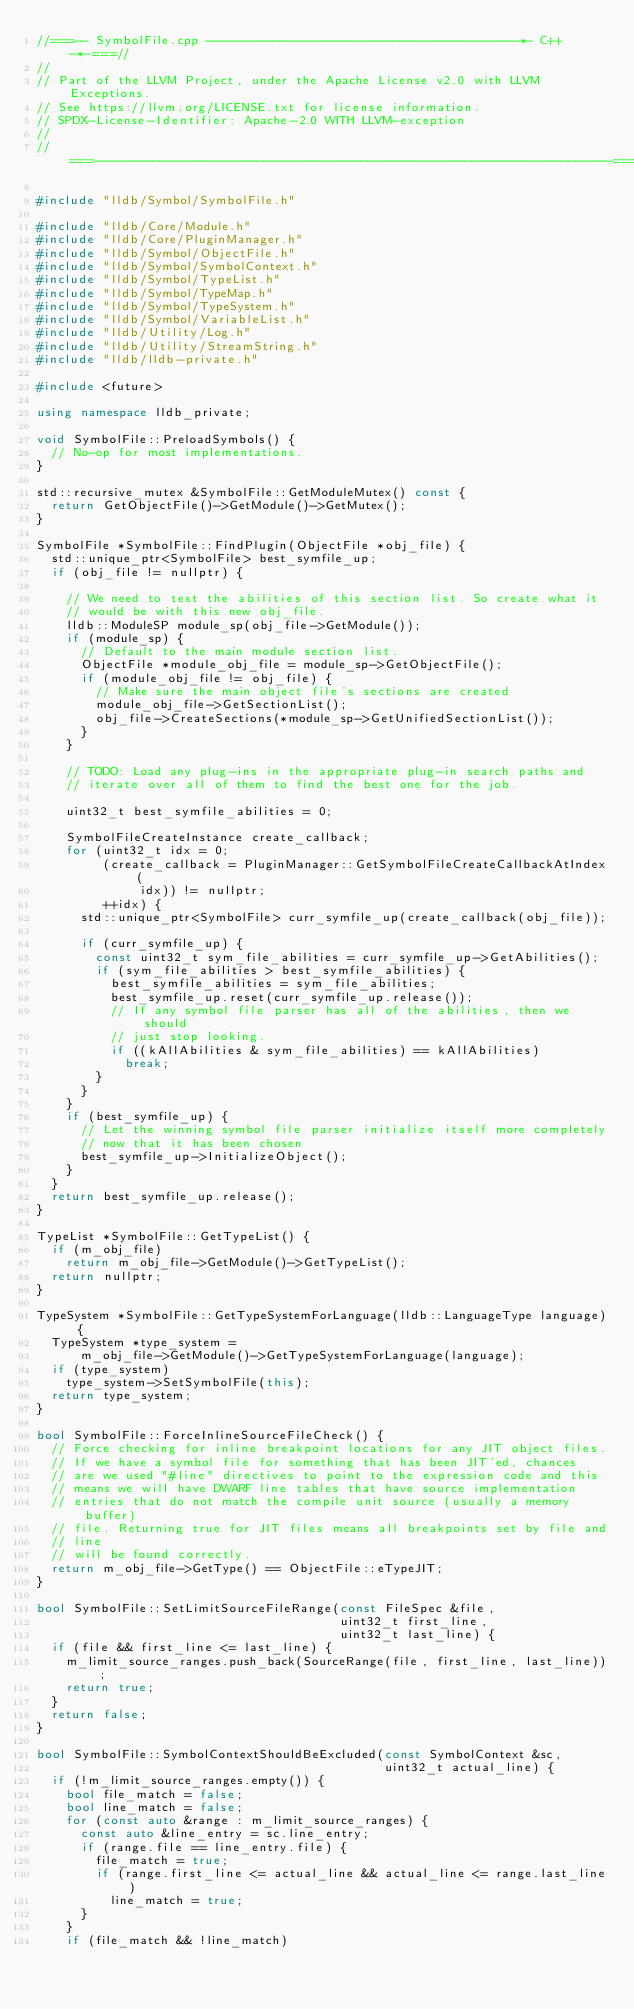<code> <loc_0><loc_0><loc_500><loc_500><_C++_>//===-- SymbolFile.cpp ------------------------------------------*- C++ -*-===//
//
// Part of the LLVM Project, under the Apache License v2.0 with LLVM Exceptions.
// See https://llvm.org/LICENSE.txt for license information.
// SPDX-License-Identifier: Apache-2.0 WITH LLVM-exception
//
//===----------------------------------------------------------------------===//

#include "lldb/Symbol/SymbolFile.h"

#include "lldb/Core/Module.h"
#include "lldb/Core/PluginManager.h"
#include "lldb/Symbol/ObjectFile.h"
#include "lldb/Symbol/SymbolContext.h"
#include "lldb/Symbol/TypeList.h"
#include "lldb/Symbol/TypeMap.h"
#include "lldb/Symbol/TypeSystem.h"
#include "lldb/Symbol/VariableList.h"
#include "lldb/Utility/Log.h"
#include "lldb/Utility/StreamString.h"
#include "lldb/lldb-private.h"

#include <future>

using namespace lldb_private;

void SymbolFile::PreloadSymbols() {
  // No-op for most implementations.
}

std::recursive_mutex &SymbolFile::GetModuleMutex() const {
  return GetObjectFile()->GetModule()->GetMutex();
}

SymbolFile *SymbolFile::FindPlugin(ObjectFile *obj_file) {
  std::unique_ptr<SymbolFile> best_symfile_up;
  if (obj_file != nullptr) {

    // We need to test the abilities of this section list. So create what it
    // would be with this new obj_file.
    lldb::ModuleSP module_sp(obj_file->GetModule());
    if (module_sp) {
      // Default to the main module section list.
      ObjectFile *module_obj_file = module_sp->GetObjectFile();
      if (module_obj_file != obj_file) {
        // Make sure the main object file's sections are created
        module_obj_file->GetSectionList();
        obj_file->CreateSections(*module_sp->GetUnifiedSectionList());
      }
    }

    // TODO: Load any plug-ins in the appropriate plug-in search paths and
    // iterate over all of them to find the best one for the job.

    uint32_t best_symfile_abilities = 0;

    SymbolFileCreateInstance create_callback;
    for (uint32_t idx = 0;
         (create_callback = PluginManager::GetSymbolFileCreateCallbackAtIndex(
              idx)) != nullptr;
         ++idx) {
      std::unique_ptr<SymbolFile> curr_symfile_up(create_callback(obj_file));

      if (curr_symfile_up) {
        const uint32_t sym_file_abilities = curr_symfile_up->GetAbilities();
        if (sym_file_abilities > best_symfile_abilities) {
          best_symfile_abilities = sym_file_abilities;
          best_symfile_up.reset(curr_symfile_up.release());
          // If any symbol file parser has all of the abilities, then we should
          // just stop looking.
          if ((kAllAbilities & sym_file_abilities) == kAllAbilities)
            break;
        }
      }
    }
    if (best_symfile_up) {
      // Let the winning symbol file parser initialize itself more completely
      // now that it has been chosen
      best_symfile_up->InitializeObject();
    }
  }
  return best_symfile_up.release();
}

TypeList *SymbolFile::GetTypeList() {
  if (m_obj_file)
    return m_obj_file->GetModule()->GetTypeList();
  return nullptr;
}

TypeSystem *SymbolFile::GetTypeSystemForLanguage(lldb::LanguageType language) {
  TypeSystem *type_system =
      m_obj_file->GetModule()->GetTypeSystemForLanguage(language);
  if (type_system)
    type_system->SetSymbolFile(this);
  return type_system;
}

bool SymbolFile::ForceInlineSourceFileCheck() {
  // Force checking for inline breakpoint locations for any JIT object files.
  // If we have a symbol file for something that has been JIT'ed, chances
  // are we used "#line" directives to point to the expression code and this
  // means we will have DWARF line tables that have source implementation
  // entries that do not match the compile unit source (usually a memory buffer)
  // file. Returning true for JIT files means all breakpoints set by file and
  // line
  // will be found correctly.
  return m_obj_file->GetType() == ObjectFile::eTypeJIT;
}

bool SymbolFile::SetLimitSourceFileRange(const FileSpec &file,
                                         uint32_t first_line,
                                         uint32_t last_line) {
  if (file && first_line <= last_line) {
    m_limit_source_ranges.push_back(SourceRange(file, first_line, last_line));
    return true;
  }
  return false;
}

bool SymbolFile::SymbolContextShouldBeExcluded(const SymbolContext &sc,
                                               uint32_t actual_line) {
  if (!m_limit_source_ranges.empty()) {
    bool file_match = false;
    bool line_match = false;
    for (const auto &range : m_limit_source_ranges) {
      const auto &line_entry = sc.line_entry;
      if (range.file == line_entry.file) {
        file_match = true;
        if (range.first_line <= actual_line && actual_line <= range.last_line)
          line_match = true;
      }
    }
    if (file_match && !line_match)</code> 